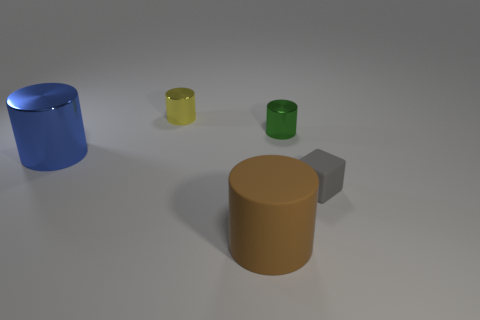Subtract 1 cylinders. How many cylinders are left? 3 Add 2 tiny gray rubber cubes. How many objects exist? 7 Subtract all cylinders. How many objects are left? 1 Add 2 small yellow metal cylinders. How many small yellow metal cylinders exist? 3 Subtract 1 blue cylinders. How many objects are left? 4 Subtract all small green rubber balls. Subtract all big brown rubber things. How many objects are left? 4 Add 1 metal cylinders. How many metal cylinders are left? 4 